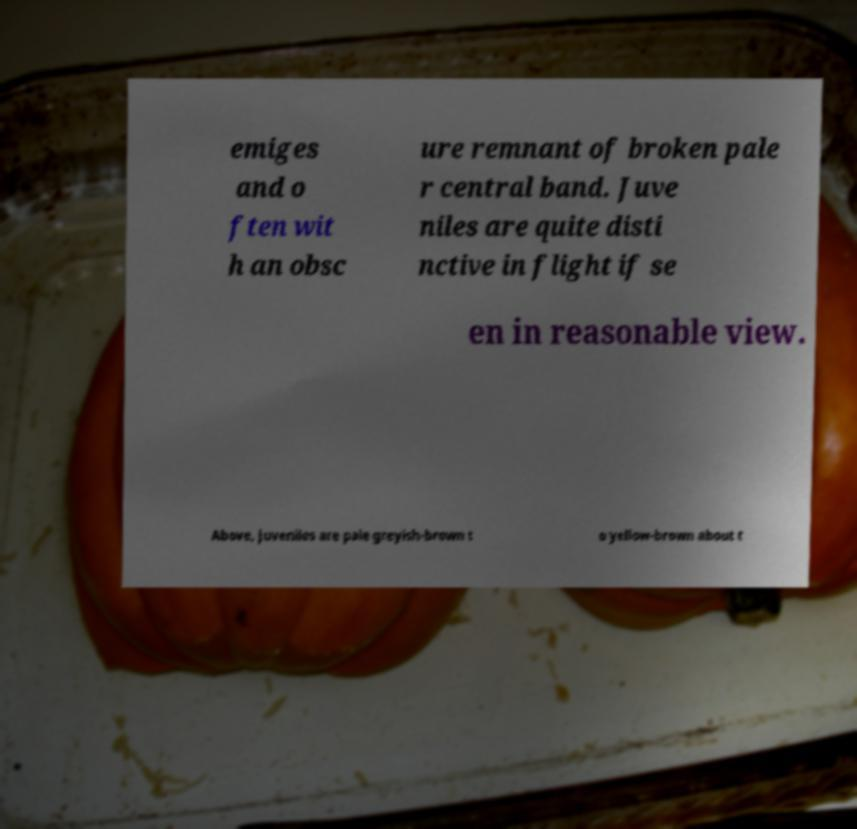There's text embedded in this image that I need extracted. Can you transcribe it verbatim? emiges and o ften wit h an obsc ure remnant of broken pale r central band. Juve niles are quite disti nctive in flight if se en in reasonable view. Above, juveniles are pale greyish-brown t o yellow-brown about t 